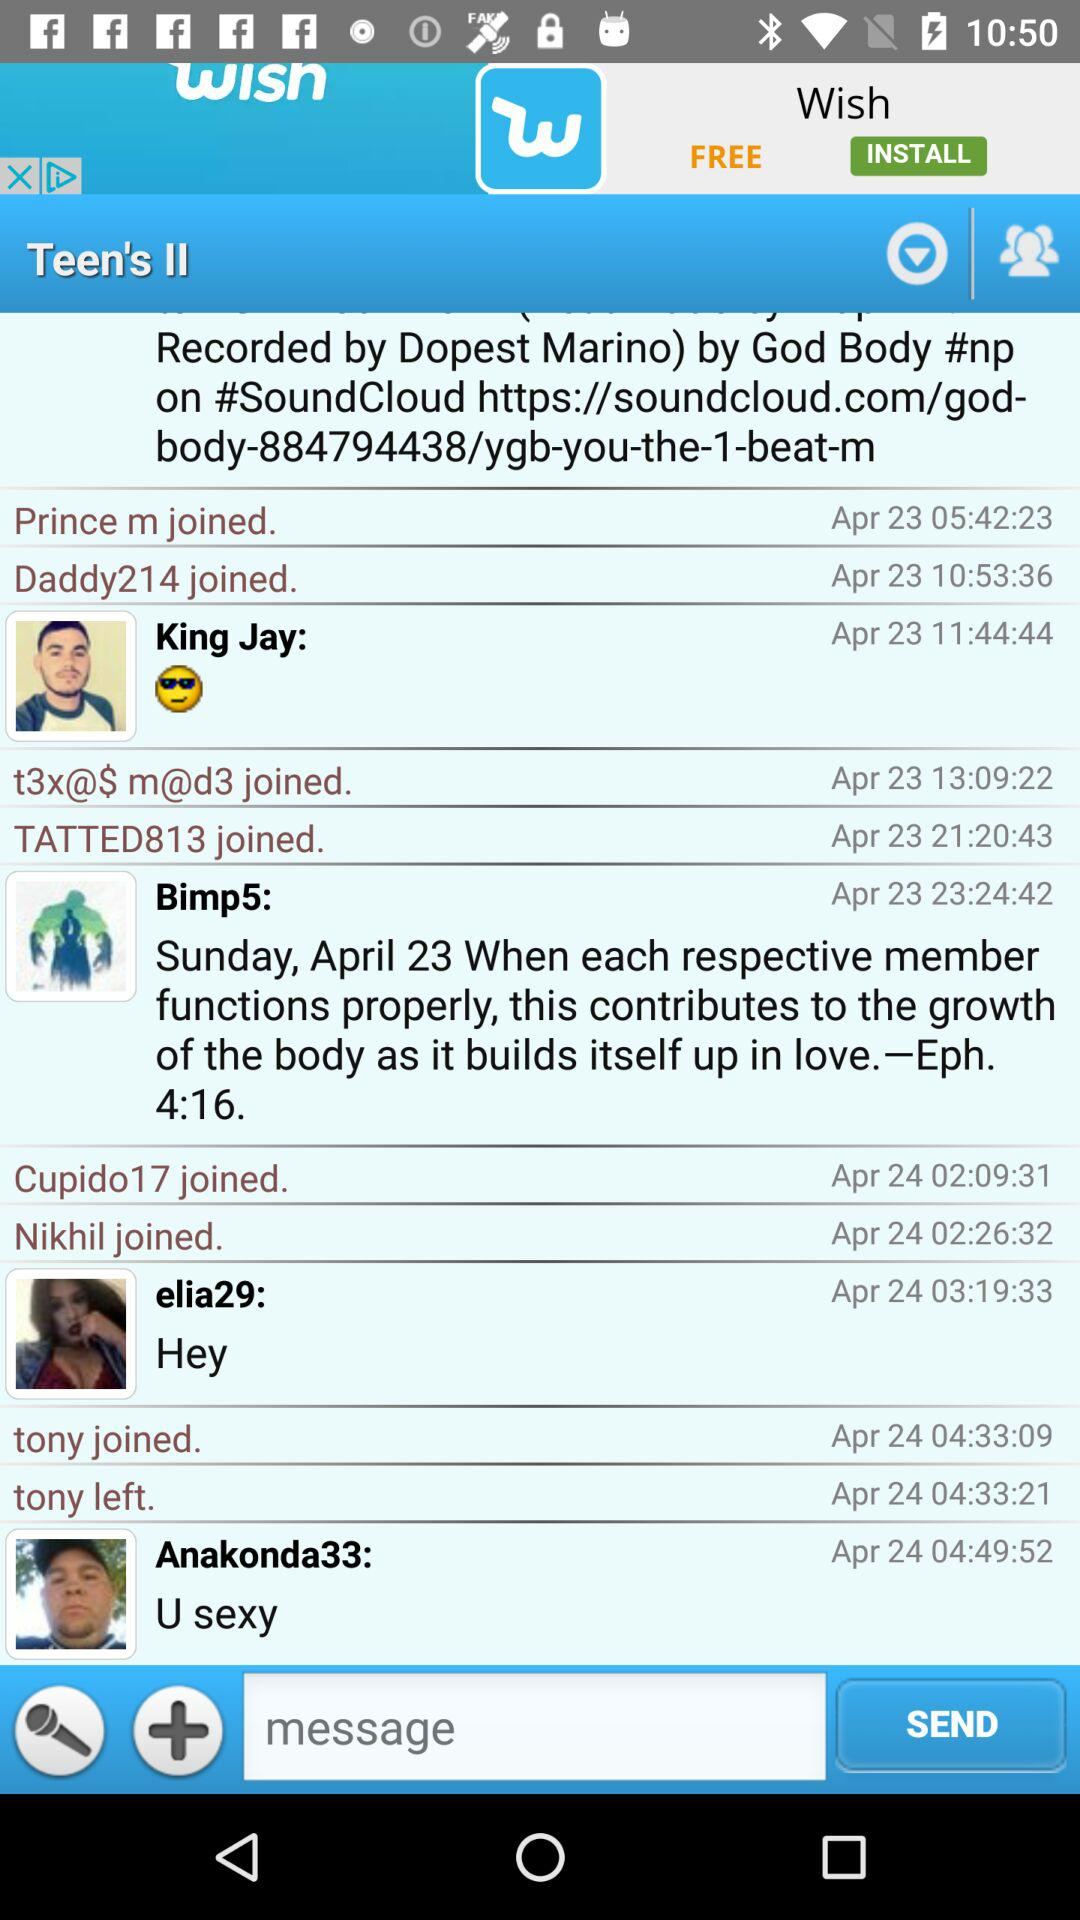When did "Daddy214" joined? "Daddy214" joined on April 23 at 10:53:36. 